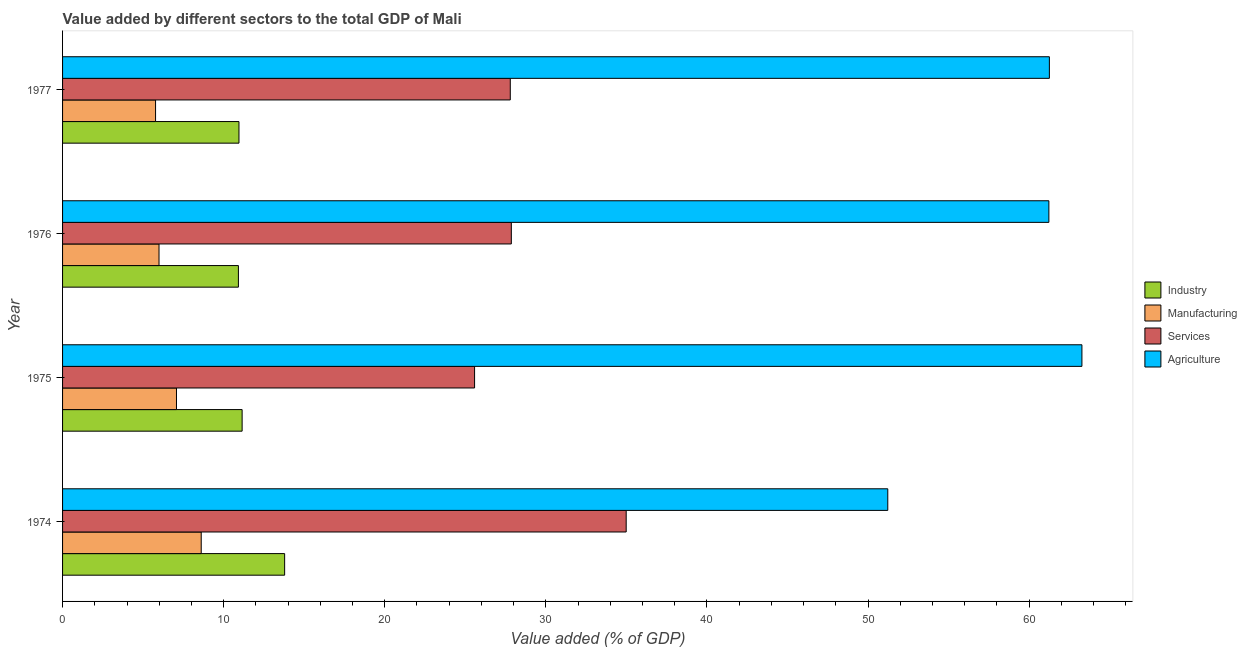How many different coloured bars are there?
Make the answer very short. 4. How many groups of bars are there?
Make the answer very short. 4. Are the number of bars on each tick of the Y-axis equal?
Provide a succinct answer. Yes. How many bars are there on the 4th tick from the bottom?
Give a very brief answer. 4. What is the label of the 2nd group of bars from the top?
Provide a succinct answer. 1976. In how many cases, is the number of bars for a given year not equal to the number of legend labels?
Offer a terse response. 0. What is the value added by agricultural sector in 1975?
Keep it short and to the point. 63.28. Across all years, what is the maximum value added by industrial sector?
Provide a short and direct response. 13.79. Across all years, what is the minimum value added by services sector?
Ensure brevity in your answer.  25.58. In which year was the value added by industrial sector maximum?
Your answer should be very brief. 1974. In which year was the value added by agricultural sector minimum?
Provide a short and direct response. 1974. What is the total value added by agricultural sector in the graph?
Ensure brevity in your answer.  236.99. What is the difference between the value added by industrial sector in 1976 and that in 1977?
Your answer should be compact. -0.04. What is the difference between the value added by manufacturing sector in 1977 and the value added by agricultural sector in 1974?
Offer a terse response. -45.45. What is the average value added by manufacturing sector per year?
Provide a short and direct response. 6.86. In the year 1975, what is the difference between the value added by manufacturing sector and value added by industrial sector?
Provide a succinct answer. -4.08. What is the ratio of the value added by services sector in 1975 to that in 1977?
Keep it short and to the point. 0.92. Is the value added by industrial sector in 1974 less than that in 1975?
Provide a short and direct response. No. What is the difference between the highest and the second highest value added by industrial sector?
Your answer should be very brief. 2.64. What is the difference between the highest and the lowest value added by services sector?
Offer a terse response. 9.41. What does the 2nd bar from the top in 1975 represents?
Give a very brief answer. Services. What does the 2nd bar from the bottom in 1977 represents?
Ensure brevity in your answer.  Manufacturing. How many bars are there?
Ensure brevity in your answer.  16. Are all the bars in the graph horizontal?
Your response must be concise. Yes. How many years are there in the graph?
Keep it short and to the point. 4. What is the difference between two consecutive major ticks on the X-axis?
Give a very brief answer. 10. Does the graph contain any zero values?
Provide a short and direct response. No. Does the graph contain grids?
Your answer should be very brief. No. How many legend labels are there?
Offer a terse response. 4. What is the title of the graph?
Offer a very short reply. Value added by different sectors to the total GDP of Mali. Does "Primary" appear as one of the legend labels in the graph?
Your response must be concise. No. What is the label or title of the X-axis?
Provide a succinct answer. Value added (% of GDP). What is the label or title of the Y-axis?
Your answer should be compact. Year. What is the Value added (% of GDP) in Industry in 1974?
Your response must be concise. 13.79. What is the Value added (% of GDP) in Manufacturing in 1974?
Ensure brevity in your answer.  8.61. What is the Value added (% of GDP) of Services in 1974?
Offer a very short reply. 34.99. What is the Value added (% of GDP) of Agriculture in 1974?
Make the answer very short. 51.23. What is the Value added (% of GDP) of Industry in 1975?
Your answer should be compact. 11.15. What is the Value added (% of GDP) of Manufacturing in 1975?
Provide a succinct answer. 7.07. What is the Value added (% of GDP) of Services in 1975?
Offer a very short reply. 25.58. What is the Value added (% of GDP) in Agriculture in 1975?
Ensure brevity in your answer.  63.28. What is the Value added (% of GDP) of Industry in 1976?
Make the answer very short. 10.92. What is the Value added (% of GDP) in Manufacturing in 1976?
Your response must be concise. 5.99. What is the Value added (% of GDP) of Services in 1976?
Offer a terse response. 27.86. What is the Value added (% of GDP) in Agriculture in 1976?
Offer a very short reply. 61.23. What is the Value added (% of GDP) in Industry in 1977?
Make the answer very short. 10.95. What is the Value added (% of GDP) in Manufacturing in 1977?
Offer a very short reply. 5.77. What is the Value added (% of GDP) in Services in 1977?
Your answer should be very brief. 27.79. What is the Value added (% of GDP) of Agriculture in 1977?
Your response must be concise. 61.26. Across all years, what is the maximum Value added (% of GDP) in Industry?
Offer a very short reply. 13.79. Across all years, what is the maximum Value added (% of GDP) of Manufacturing?
Keep it short and to the point. 8.61. Across all years, what is the maximum Value added (% of GDP) of Services?
Provide a succinct answer. 34.99. Across all years, what is the maximum Value added (% of GDP) in Agriculture?
Your answer should be compact. 63.28. Across all years, what is the minimum Value added (% of GDP) in Industry?
Keep it short and to the point. 10.92. Across all years, what is the minimum Value added (% of GDP) of Manufacturing?
Your answer should be compact. 5.77. Across all years, what is the minimum Value added (% of GDP) in Services?
Ensure brevity in your answer.  25.58. Across all years, what is the minimum Value added (% of GDP) in Agriculture?
Offer a terse response. 51.23. What is the total Value added (% of GDP) in Industry in the graph?
Make the answer very short. 46.8. What is the total Value added (% of GDP) in Manufacturing in the graph?
Your answer should be compact. 27.44. What is the total Value added (% of GDP) of Services in the graph?
Provide a short and direct response. 116.21. What is the total Value added (% of GDP) in Agriculture in the graph?
Offer a very short reply. 236.99. What is the difference between the Value added (% of GDP) in Industry in 1974 and that in 1975?
Your answer should be very brief. 2.64. What is the difference between the Value added (% of GDP) in Manufacturing in 1974 and that in 1975?
Your answer should be compact. 1.54. What is the difference between the Value added (% of GDP) of Services in 1974 and that in 1975?
Offer a terse response. 9.41. What is the difference between the Value added (% of GDP) of Agriculture in 1974 and that in 1975?
Provide a succinct answer. -12.05. What is the difference between the Value added (% of GDP) in Industry in 1974 and that in 1976?
Your answer should be compact. 2.87. What is the difference between the Value added (% of GDP) in Manufacturing in 1974 and that in 1976?
Your answer should be very brief. 2.62. What is the difference between the Value added (% of GDP) in Services in 1974 and that in 1976?
Offer a terse response. 7.13. What is the difference between the Value added (% of GDP) of Agriculture in 1974 and that in 1976?
Provide a short and direct response. -10. What is the difference between the Value added (% of GDP) of Industry in 1974 and that in 1977?
Your answer should be very brief. 2.83. What is the difference between the Value added (% of GDP) in Manufacturing in 1974 and that in 1977?
Keep it short and to the point. 2.83. What is the difference between the Value added (% of GDP) of Services in 1974 and that in 1977?
Give a very brief answer. 7.2. What is the difference between the Value added (% of GDP) of Agriculture in 1974 and that in 1977?
Your answer should be very brief. -10.03. What is the difference between the Value added (% of GDP) of Industry in 1975 and that in 1976?
Make the answer very short. 0.23. What is the difference between the Value added (% of GDP) of Manufacturing in 1975 and that in 1976?
Your response must be concise. 1.08. What is the difference between the Value added (% of GDP) in Services in 1975 and that in 1976?
Offer a terse response. -2.28. What is the difference between the Value added (% of GDP) of Agriculture in 1975 and that in 1976?
Make the answer very short. 2.05. What is the difference between the Value added (% of GDP) of Industry in 1975 and that in 1977?
Provide a succinct answer. 0.2. What is the difference between the Value added (% of GDP) of Manufacturing in 1975 and that in 1977?
Provide a short and direct response. 1.3. What is the difference between the Value added (% of GDP) of Services in 1975 and that in 1977?
Give a very brief answer. -2.22. What is the difference between the Value added (% of GDP) in Agriculture in 1975 and that in 1977?
Keep it short and to the point. 2.02. What is the difference between the Value added (% of GDP) in Industry in 1976 and that in 1977?
Your answer should be compact. -0.04. What is the difference between the Value added (% of GDP) of Manufacturing in 1976 and that in 1977?
Offer a very short reply. 0.21. What is the difference between the Value added (% of GDP) in Services in 1976 and that in 1977?
Give a very brief answer. 0.07. What is the difference between the Value added (% of GDP) in Agriculture in 1976 and that in 1977?
Make the answer very short. -0.03. What is the difference between the Value added (% of GDP) of Industry in 1974 and the Value added (% of GDP) of Manufacturing in 1975?
Your answer should be compact. 6.71. What is the difference between the Value added (% of GDP) of Industry in 1974 and the Value added (% of GDP) of Services in 1975?
Your answer should be compact. -11.79. What is the difference between the Value added (% of GDP) of Industry in 1974 and the Value added (% of GDP) of Agriculture in 1975?
Give a very brief answer. -49.49. What is the difference between the Value added (% of GDP) of Manufacturing in 1974 and the Value added (% of GDP) of Services in 1975?
Your answer should be compact. -16.97. What is the difference between the Value added (% of GDP) of Manufacturing in 1974 and the Value added (% of GDP) of Agriculture in 1975?
Your answer should be very brief. -54.67. What is the difference between the Value added (% of GDP) of Services in 1974 and the Value added (% of GDP) of Agriculture in 1975?
Keep it short and to the point. -28.29. What is the difference between the Value added (% of GDP) in Industry in 1974 and the Value added (% of GDP) in Manufacturing in 1976?
Provide a short and direct response. 7.8. What is the difference between the Value added (% of GDP) of Industry in 1974 and the Value added (% of GDP) of Services in 1976?
Your response must be concise. -14.07. What is the difference between the Value added (% of GDP) in Industry in 1974 and the Value added (% of GDP) in Agriculture in 1976?
Offer a terse response. -47.44. What is the difference between the Value added (% of GDP) of Manufacturing in 1974 and the Value added (% of GDP) of Services in 1976?
Your answer should be compact. -19.25. What is the difference between the Value added (% of GDP) of Manufacturing in 1974 and the Value added (% of GDP) of Agriculture in 1976?
Your answer should be very brief. -52.62. What is the difference between the Value added (% of GDP) of Services in 1974 and the Value added (% of GDP) of Agriculture in 1976?
Give a very brief answer. -26.24. What is the difference between the Value added (% of GDP) in Industry in 1974 and the Value added (% of GDP) in Manufacturing in 1977?
Provide a short and direct response. 8.01. What is the difference between the Value added (% of GDP) of Industry in 1974 and the Value added (% of GDP) of Services in 1977?
Keep it short and to the point. -14.01. What is the difference between the Value added (% of GDP) of Industry in 1974 and the Value added (% of GDP) of Agriculture in 1977?
Give a very brief answer. -47.47. What is the difference between the Value added (% of GDP) in Manufacturing in 1974 and the Value added (% of GDP) in Services in 1977?
Provide a succinct answer. -19.18. What is the difference between the Value added (% of GDP) of Manufacturing in 1974 and the Value added (% of GDP) of Agriculture in 1977?
Provide a succinct answer. -52.65. What is the difference between the Value added (% of GDP) of Services in 1974 and the Value added (% of GDP) of Agriculture in 1977?
Your answer should be compact. -26.27. What is the difference between the Value added (% of GDP) in Industry in 1975 and the Value added (% of GDP) in Manufacturing in 1976?
Keep it short and to the point. 5.16. What is the difference between the Value added (% of GDP) of Industry in 1975 and the Value added (% of GDP) of Services in 1976?
Make the answer very short. -16.71. What is the difference between the Value added (% of GDP) of Industry in 1975 and the Value added (% of GDP) of Agriculture in 1976?
Provide a short and direct response. -50.08. What is the difference between the Value added (% of GDP) in Manufacturing in 1975 and the Value added (% of GDP) in Services in 1976?
Provide a succinct answer. -20.79. What is the difference between the Value added (% of GDP) of Manufacturing in 1975 and the Value added (% of GDP) of Agriculture in 1976?
Your answer should be very brief. -54.16. What is the difference between the Value added (% of GDP) in Services in 1975 and the Value added (% of GDP) in Agriculture in 1976?
Provide a succinct answer. -35.65. What is the difference between the Value added (% of GDP) of Industry in 1975 and the Value added (% of GDP) of Manufacturing in 1977?
Your answer should be very brief. 5.37. What is the difference between the Value added (% of GDP) in Industry in 1975 and the Value added (% of GDP) in Services in 1977?
Offer a terse response. -16.65. What is the difference between the Value added (% of GDP) in Industry in 1975 and the Value added (% of GDP) in Agriculture in 1977?
Your answer should be very brief. -50.11. What is the difference between the Value added (% of GDP) in Manufacturing in 1975 and the Value added (% of GDP) in Services in 1977?
Give a very brief answer. -20.72. What is the difference between the Value added (% of GDP) of Manufacturing in 1975 and the Value added (% of GDP) of Agriculture in 1977?
Provide a short and direct response. -54.19. What is the difference between the Value added (% of GDP) of Services in 1975 and the Value added (% of GDP) of Agriculture in 1977?
Your response must be concise. -35.68. What is the difference between the Value added (% of GDP) in Industry in 1976 and the Value added (% of GDP) in Manufacturing in 1977?
Your response must be concise. 5.14. What is the difference between the Value added (% of GDP) in Industry in 1976 and the Value added (% of GDP) in Services in 1977?
Your answer should be very brief. -16.88. What is the difference between the Value added (% of GDP) of Industry in 1976 and the Value added (% of GDP) of Agriculture in 1977?
Offer a terse response. -50.34. What is the difference between the Value added (% of GDP) in Manufacturing in 1976 and the Value added (% of GDP) in Services in 1977?
Offer a terse response. -21.8. What is the difference between the Value added (% of GDP) of Manufacturing in 1976 and the Value added (% of GDP) of Agriculture in 1977?
Provide a short and direct response. -55.27. What is the difference between the Value added (% of GDP) of Services in 1976 and the Value added (% of GDP) of Agriculture in 1977?
Your response must be concise. -33.4. What is the average Value added (% of GDP) of Industry per year?
Provide a short and direct response. 11.7. What is the average Value added (% of GDP) in Manufacturing per year?
Keep it short and to the point. 6.86. What is the average Value added (% of GDP) in Services per year?
Keep it short and to the point. 29.05. What is the average Value added (% of GDP) of Agriculture per year?
Your answer should be compact. 59.25. In the year 1974, what is the difference between the Value added (% of GDP) of Industry and Value added (% of GDP) of Manufacturing?
Give a very brief answer. 5.18. In the year 1974, what is the difference between the Value added (% of GDP) of Industry and Value added (% of GDP) of Services?
Give a very brief answer. -21.2. In the year 1974, what is the difference between the Value added (% of GDP) in Industry and Value added (% of GDP) in Agriculture?
Ensure brevity in your answer.  -37.44. In the year 1974, what is the difference between the Value added (% of GDP) in Manufacturing and Value added (% of GDP) in Services?
Provide a short and direct response. -26.38. In the year 1974, what is the difference between the Value added (% of GDP) of Manufacturing and Value added (% of GDP) of Agriculture?
Offer a terse response. -42.62. In the year 1974, what is the difference between the Value added (% of GDP) in Services and Value added (% of GDP) in Agriculture?
Ensure brevity in your answer.  -16.24. In the year 1975, what is the difference between the Value added (% of GDP) of Industry and Value added (% of GDP) of Manufacturing?
Offer a terse response. 4.08. In the year 1975, what is the difference between the Value added (% of GDP) of Industry and Value added (% of GDP) of Services?
Your response must be concise. -14.43. In the year 1975, what is the difference between the Value added (% of GDP) in Industry and Value added (% of GDP) in Agriculture?
Keep it short and to the point. -52.13. In the year 1975, what is the difference between the Value added (% of GDP) of Manufacturing and Value added (% of GDP) of Services?
Provide a succinct answer. -18.5. In the year 1975, what is the difference between the Value added (% of GDP) in Manufacturing and Value added (% of GDP) in Agriculture?
Make the answer very short. -56.21. In the year 1975, what is the difference between the Value added (% of GDP) of Services and Value added (% of GDP) of Agriculture?
Keep it short and to the point. -37.7. In the year 1976, what is the difference between the Value added (% of GDP) of Industry and Value added (% of GDP) of Manufacturing?
Ensure brevity in your answer.  4.93. In the year 1976, what is the difference between the Value added (% of GDP) in Industry and Value added (% of GDP) in Services?
Make the answer very short. -16.94. In the year 1976, what is the difference between the Value added (% of GDP) of Industry and Value added (% of GDP) of Agriculture?
Ensure brevity in your answer.  -50.31. In the year 1976, what is the difference between the Value added (% of GDP) in Manufacturing and Value added (% of GDP) in Services?
Offer a terse response. -21.87. In the year 1976, what is the difference between the Value added (% of GDP) of Manufacturing and Value added (% of GDP) of Agriculture?
Give a very brief answer. -55.24. In the year 1976, what is the difference between the Value added (% of GDP) in Services and Value added (% of GDP) in Agriculture?
Ensure brevity in your answer.  -33.37. In the year 1977, what is the difference between the Value added (% of GDP) in Industry and Value added (% of GDP) in Manufacturing?
Make the answer very short. 5.18. In the year 1977, what is the difference between the Value added (% of GDP) in Industry and Value added (% of GDP) in Services?
Offer a terse response. -16.84. In the year 1977, what is the difference between the Value added (% of GDP) in Industry and Value added (% of GDP) in Agriculture?
Your answer should be very brief. -50.31. In the year 1977, what is the difference between the Value added (% of GDP) in Manufacturing and Value added (% of GDP) in Services?
Offer a terse response. -22.02. In the year 1977, what is the difference between the Value added (% of GDP) in Manufacturing and Value added (% of GDP) in Agriculture?
Make the answer very short. -55.48. In the year 1977, what is the difference between the Value added (% of GDP) in Services and Value added (% of GDP) in Agriculture?
Ensure brevity in your answer.  -33.47. What is the ratio of the Value added (% of GDP) in Industry in 1974 to that in 1975?
Offer a very short reply. 1.24. What is the ratio of the Value added (% of GDP) of Manufacturing in 1974 to that in 1975?
Keep it short and to the point. 1.22. What is the ratio of the Value added (% of GDP) in Services in 1974 to that in 1975?
Your answer should be compact. 1.37. What is the ratio of the Value added (% of GDP) of Agriculture in 1974 to that in 1975?
Keep it short and to the point. 0.81. What is the ratio of the Value added (% of GDP) of Industry in 1974 to that in 1976?
Ensure brevity in your answer.  1.26. What is the ratio of the Value added (% of GDP) of Manufacturing in 1974 to that in 1976?
Keep it short and to the point. 1.44. What is the ratio of the Value added (% of GDP) of Services in 1974 to that in 1976?
Offer a terse response. 1.26. What is the ratio of the Value added (% of GDP) of Agriculture in 1974 to that in 1976?
Offer a terse response. 0.84. What is the ratio of the Value added (% of GDP) in Industry in 1974 to that in 1977?
Provide a short and direct response. 1.26. What is the ratio of the Value added (% of GDP) of Manufacturing in 1974 to that in 1977?
Offer a very short reply. 1.49. What is the ratio of the Value added (% of GDP) in Services in 1974 to that in 1977?
Provide a succinct answer. 1.26. What is the ratio of the Value added (% of GDP) of Agriculture in 1974 to that in 1977?
Provide a succinct answer. 0.84. What is the ratio of the Value added (% of GDP) of Industry in 1975 to that in 1976?
Your answer should be compact. 1.02. What is the ratio of the Value added (% of GDP) in Manufacturing in 1975 to that in 1976?
Provide a short and direct response. 1.18. What is the ratio of the Value added (% of GDP) in Services in 1975 to that in 1976?
Make the answer very short. 0.92. What is the ratio of the Value added (% of GDP) of Agriculture in 1975 to that in 1976?
Offer a terse response. 1.03. What is the ratio of the Value added (% of GDP) in Industry in 1975 to that in 1977?
Your answer should be compact. 1.02. What is the ratio of the Value added (% of GDP) in Manufacturing in 1975 to that in 1977?
Your answer should be very brief. 1.23. What is the ratio of the Value added (% of GDP) of Services in 1975 to that in 1977?
Provide a short and direct response. 0.92. What is the ratio of the Value added (% of GDP) in Agriculture in 1975 to that in 1977?
Your response must be concise. 1.03. What is the ratio of the Value added (% of GDP) in Manufacturing in 1976 to that in 1977?
Your answer should be compact. 1.04. What is the difference between the highest and the second highest Value added (% of GDP) in Industry?
Provide a short and direct response. 2.64. What is the difference between the highest and the second highest Value added (% of GDP) of Manufacturing?
Ensure brevity in your answer.  1.54. What is the difference between the highest and the second highest Value added (% of GDP) of Services?
Provide a short and direct response. 7.13. What is the difference between the highest and the second highest Value added (% of GDP) of Agriculture?
Your response must be concise. 2.02. What is the difference between the highest and the lowest Value added (% of GDP) of Industry?
Offer a very short reply. 2.87. What is the difference between the highest and the lowest Value added (% of GDP) in Manufacturing?
Ensure brevity in your answer.  2.83. What is the difference between the highest and the lowest Value added (% of GDP) of Services?
Keep it short and to the point. 9.41. What is the difference between the highest and the lowest Value added (% of GDP) of Agriculture?
Offer a very short reply. 12.05. 